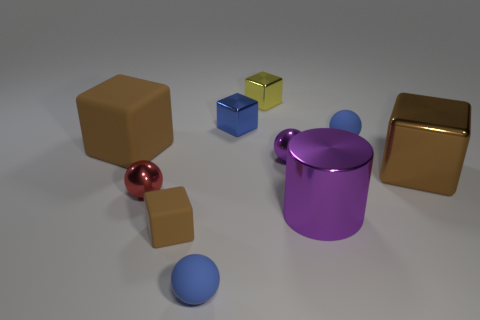How many brown cubes must be subtracted to get 1 brown cubes? 2 Subtract all red cylinders. How many brown cubes are left? 3 Subtract 1 cubes. How many cubes are left? 4 Subtract all blue cubes. How many cubes are left? 4 Subtract all yellow shiny blocks. How many blocks are left? 4 Subtract all blue blocks. Subtract all blue cylinders. How many blocks are left? 4 Subtract all cylinders. How many objects are left? 9 Subtract 0 red cylinders. How many objects are left? 10 Subtract all large brown blocks. Subtract all small blue metal objects. How many objects are left? 7 Add 9 cylinders. How many cylinders are left? 10 